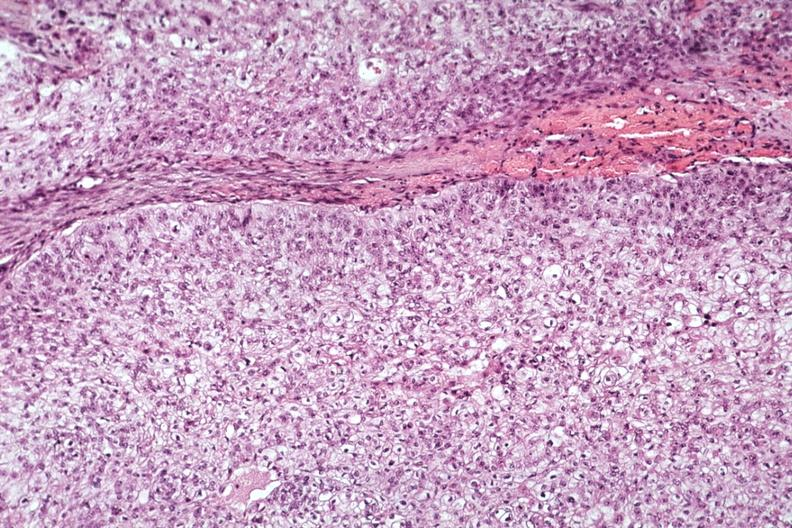what is present?
Answer the question using a single word or phrase. Endocrine 